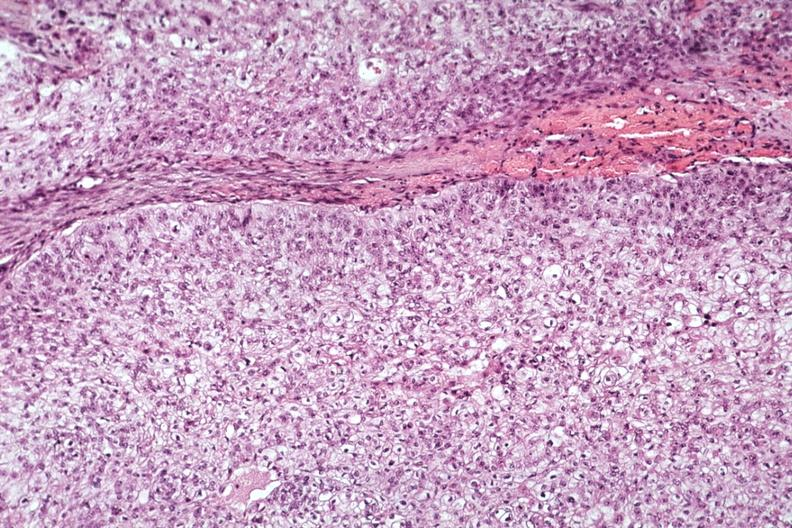what is present?
Answer the question using a single word or phrase. Endocrine 